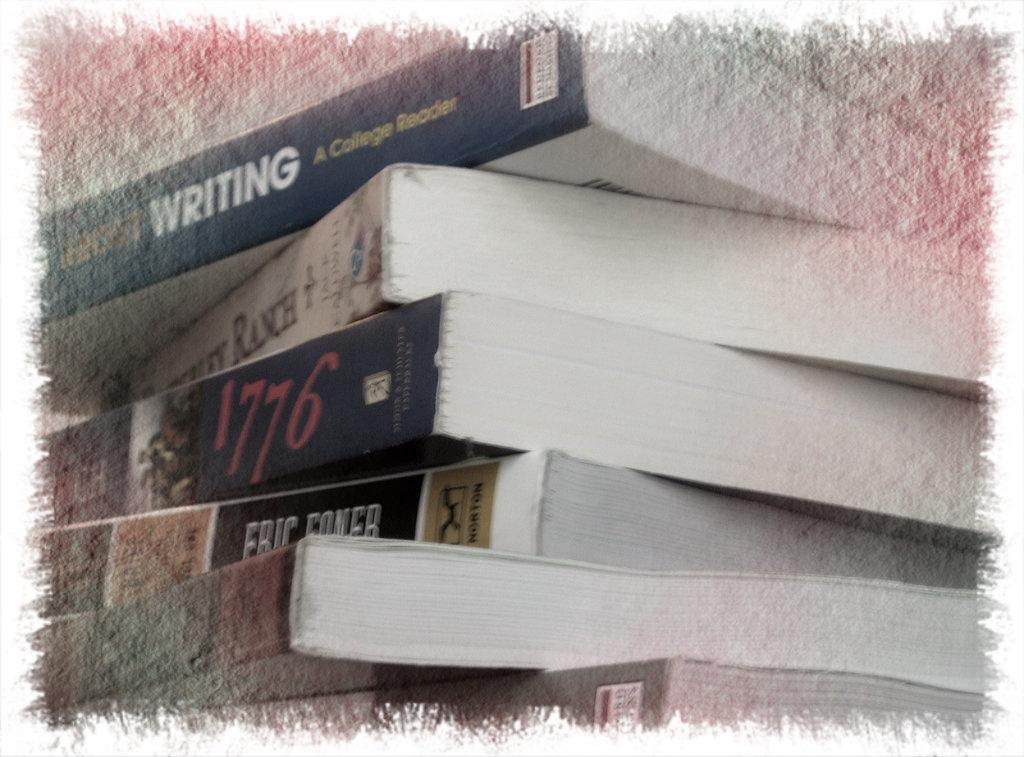Provide a one-sentence caption for the provided image. Several books stacked together with one mentioning the year 1776. 